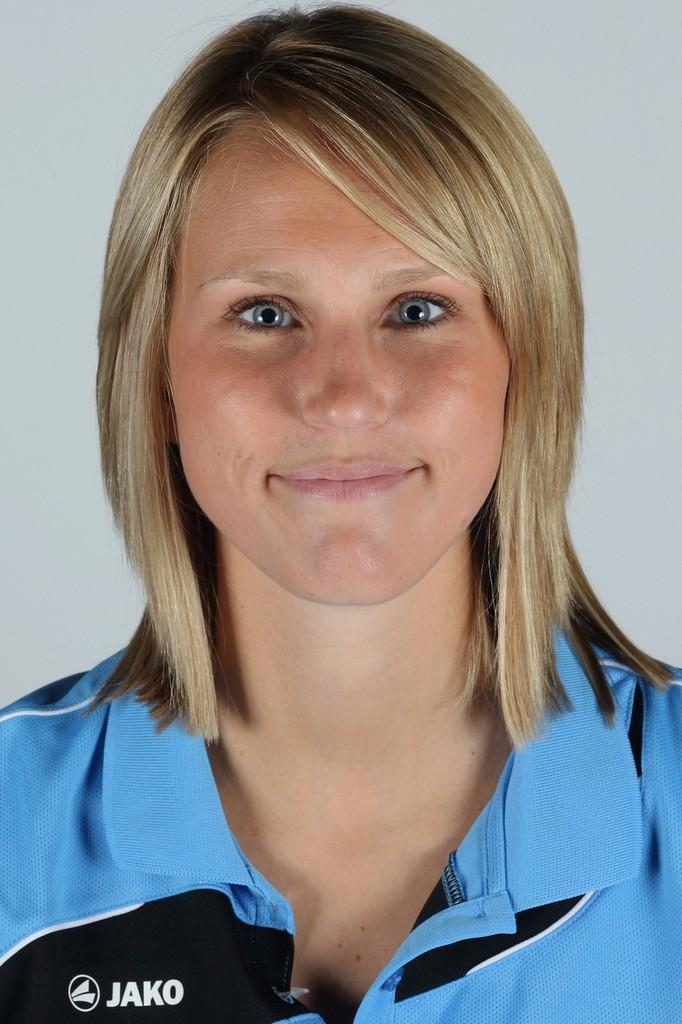<image>
Render a clear and concise summary of the photo. A girl wearing a blue shirt with the word Jako on it is smiling. 